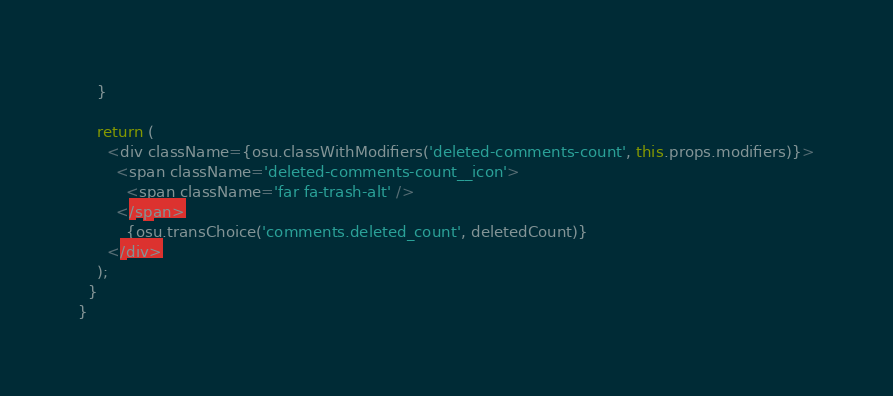Convert code to text. <code><loc_0><loc_0><loc_500><loc_500><_TypeScript_>    }

    return (
      <div className={osu.classWithModifiers('deleted-comments-count', this.props.modifiers)}>
        <span className='deleted-comments-count__icon'>
          <span className='far fa-trash-alt' />
        </span>
          {osu.transChoice('comments.deleted_count', deletedCount)}
      </div>
    );
  }
}
</code> 